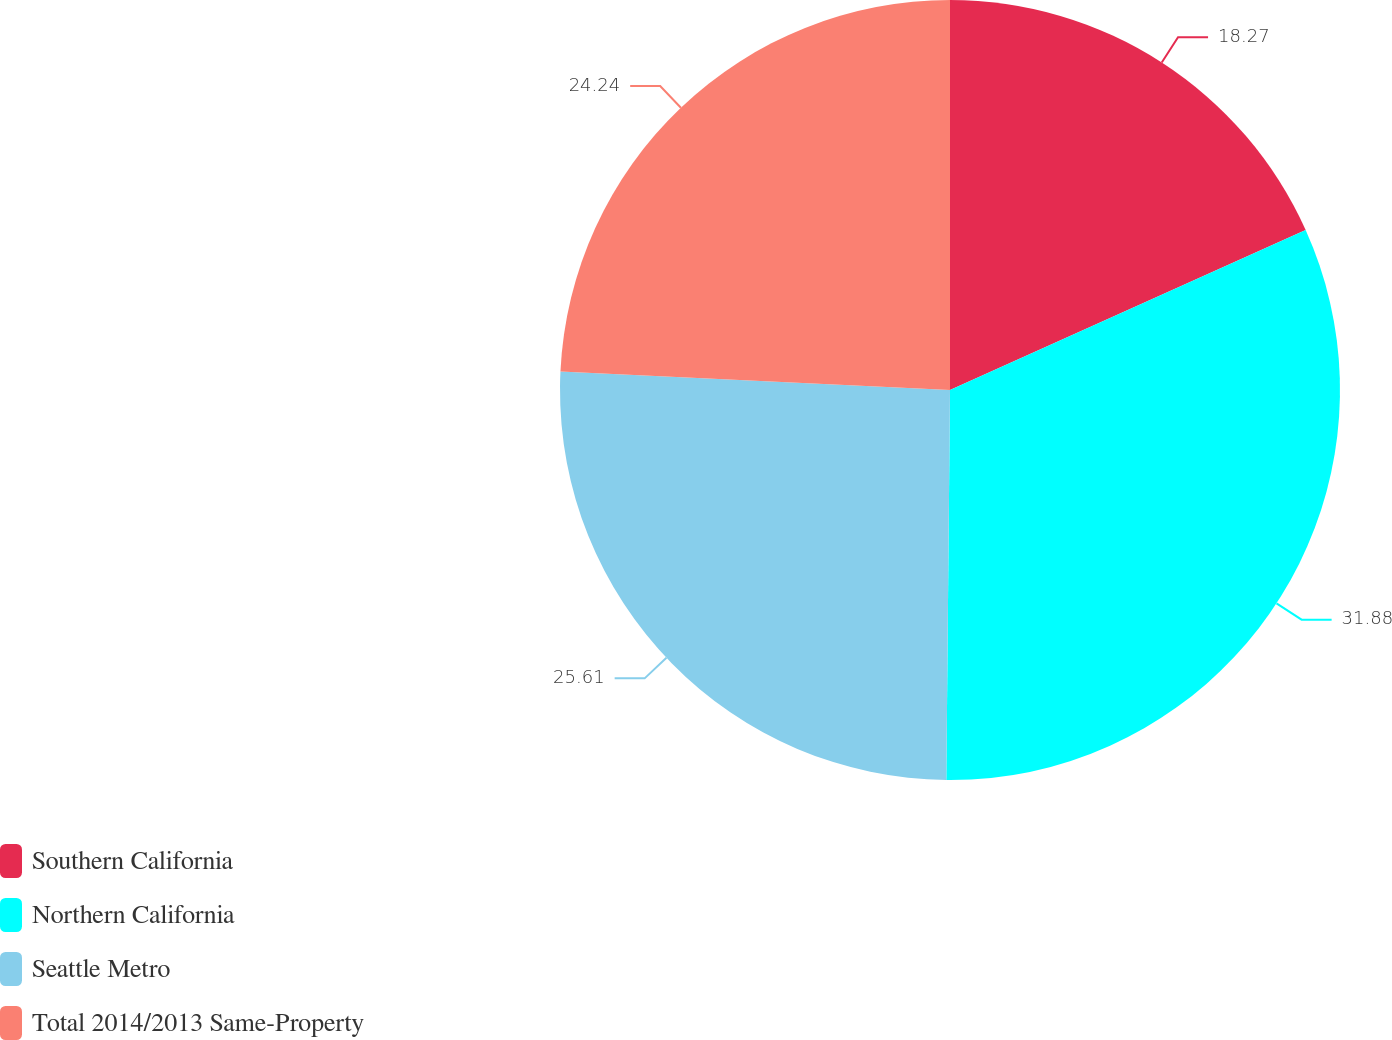Convert chart to OTSL. <chart><loc_0><loc_0><loc_500><loc_500><pie_chart><fcel>Southern California<fcel>Northern California<fcel>Seattle Metro<fcel>Total 2014/2013 Same-Property<nl><fcel>18.27%<fcel>31.88%<fcel>25.61%<fcel>24.24%<nl></chart> 